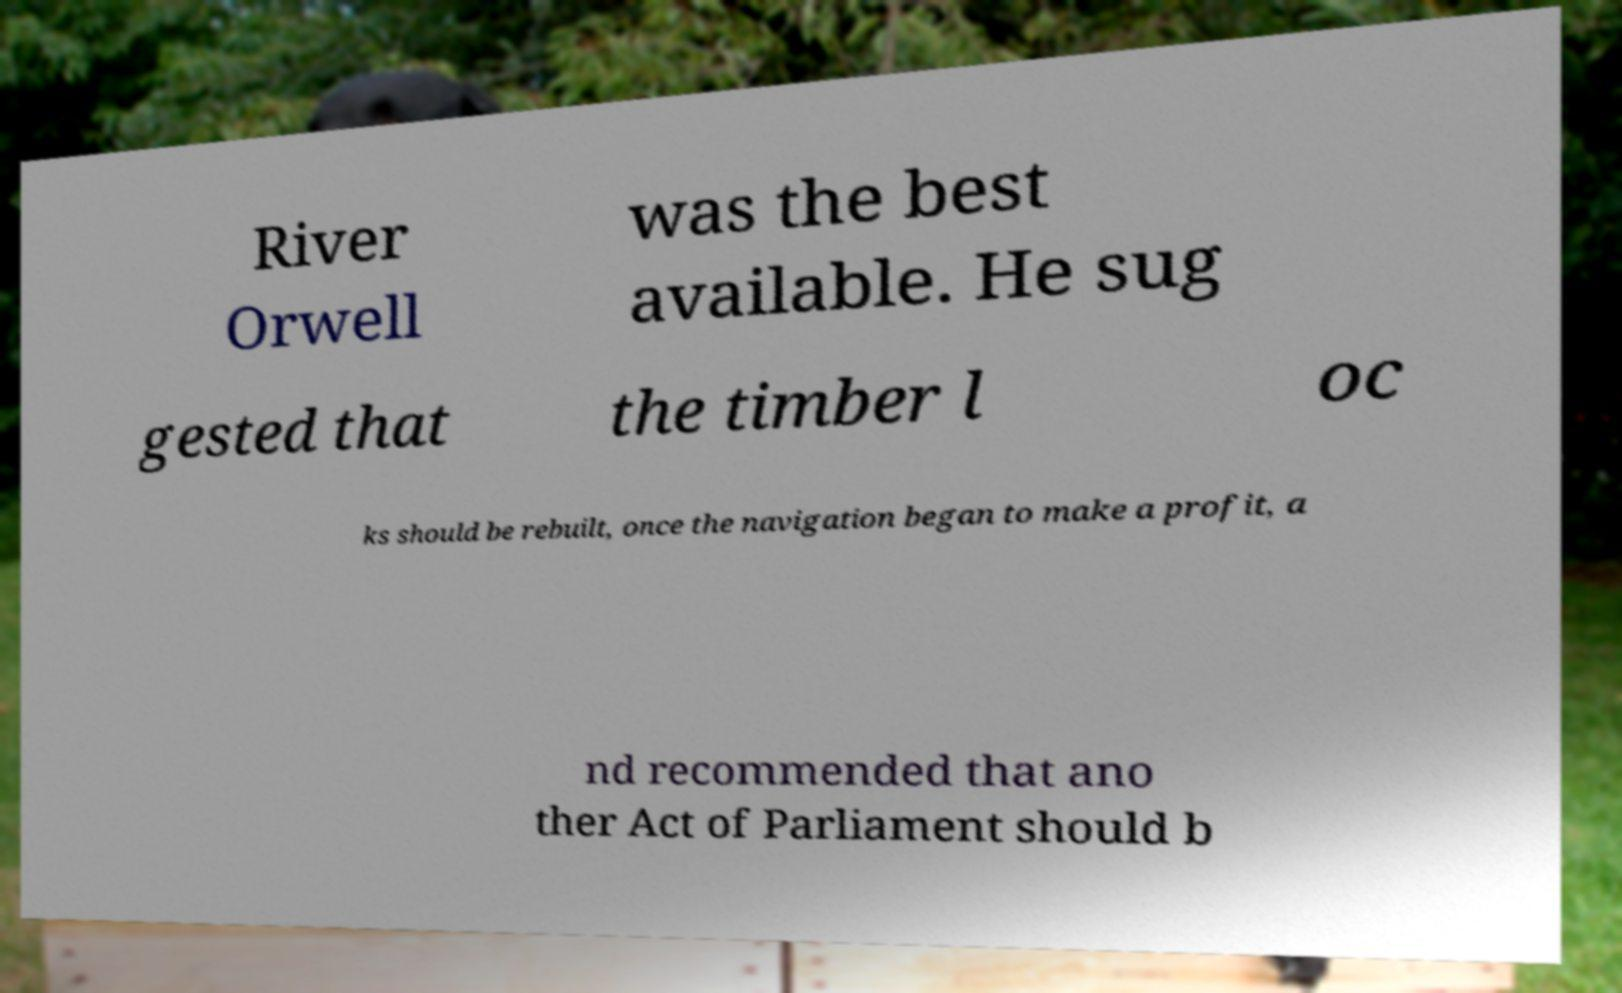For documentation purposes, I need the text within this image transcribed. Could you provide that? River Orwell was the best available. He sug gested that the timber l oc ks should be rebuilt, once the navigation began to make a profit, a nd recommended that ano ther Act of Parliament should b 